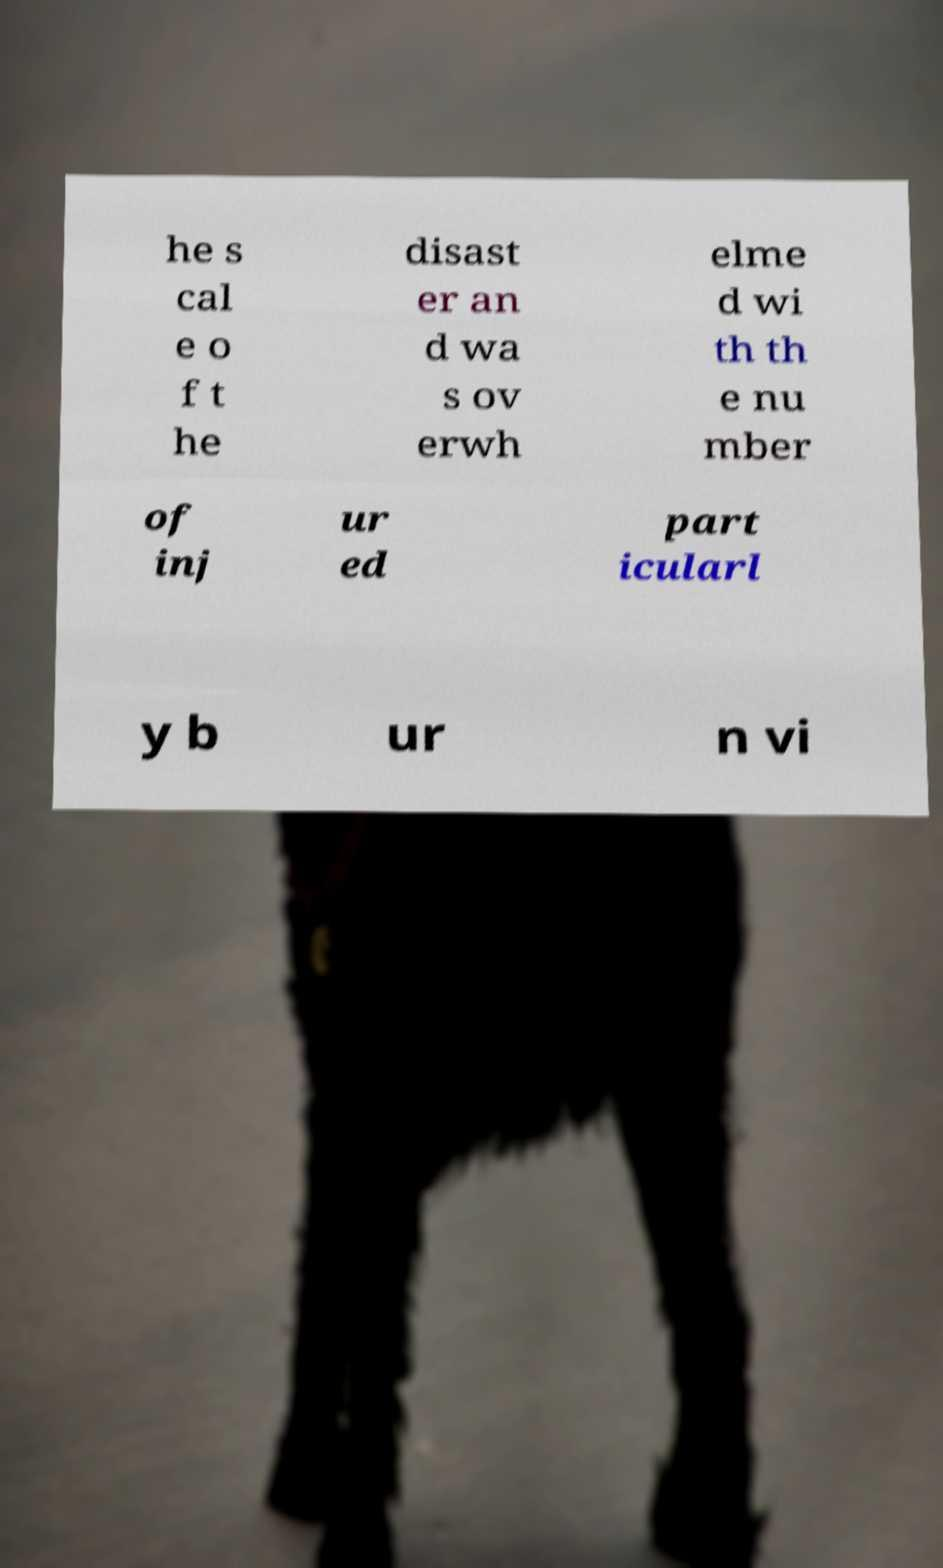Can you accurately transcribe the text from the provided image for me? he s cal e o f t he disast er an d wa s ov erwh elme d wi th th e nu mber of inj ur ed part icularl y b ur n vi 